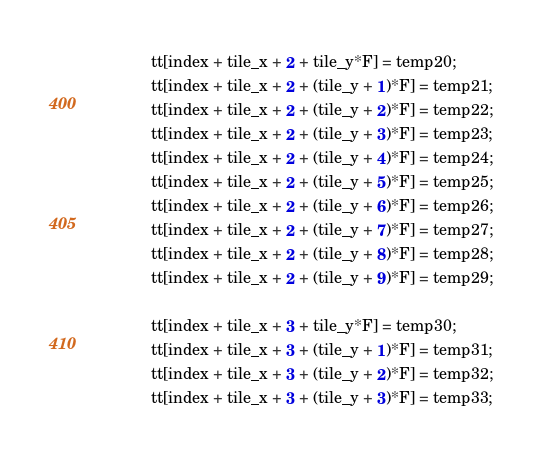Convert code to text. <code><loc_0><loc_0><loc_500><loc_500><_Cuda_>			tt[index + tile_x + 2 + tile_y*F] = temp20;
			tt[index + tile_x + 2 + (tile_y + 1)*F] = temp21;
			tt[index + tile_x + 2 + (tile_y + 2)*F] = temp22;
			tt[index + tile_x + 2 + (tile_y + 3)*F] = temp23;
			tt[index + tile_x + 2 + (tile_y + 4)*F] = temp24;
			tt[index + tile_x + 2 + (tile_y + 5)*F] = temp25;
			tt[index + tile_x + 2 + (tile_y + 6)*F] = temp26;
			tt[index + tile_x + 2 + (tile_y + 7)*F] = temp27;
			tt[index + tile_x + 2 + (tile_y + 8)*F] = temp28;
			tt[index + tile_x + 2 + (tile_y + 9)*F] = temp29;

			tt[index + tile_x + 3 + tile_y*F] = temp30;
			tt[index + tile_x + 3 + (tile_y + 1)*F] = temp31;
			tt[index + tile_x + 3 + (tile_y + 2)*F] = temp32;
			tt[index + tile_x + 3 + (tile_y + 3)*F] = temp33;</code> 